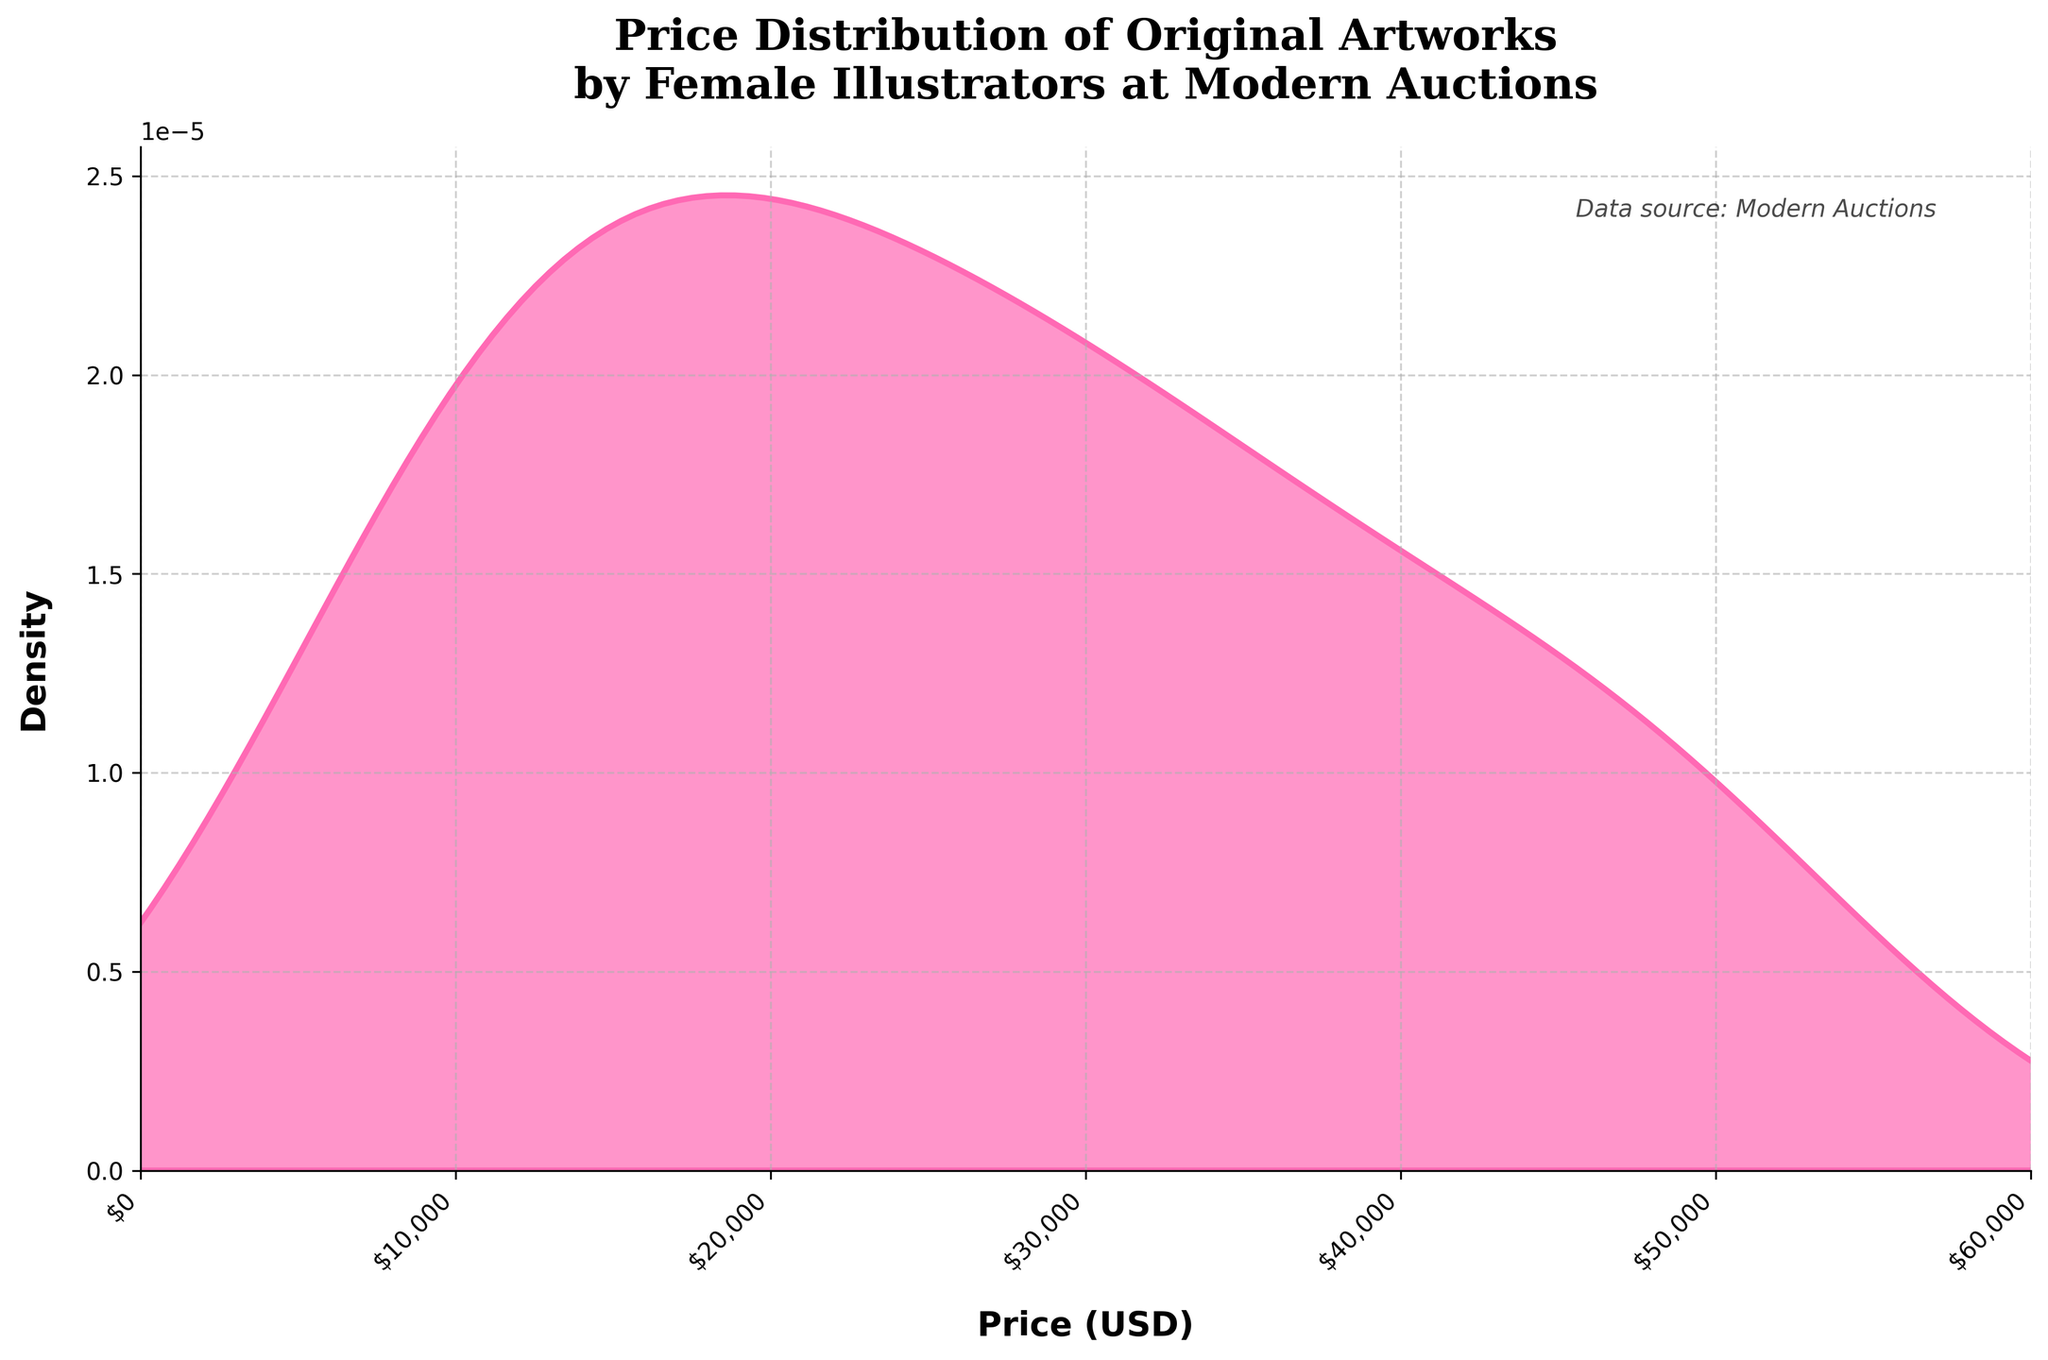What's the title of the plot? The title is usually located at the top of the plot. Here, the title of the plot reads: "Price Distribution of Original Artworks by Female Illustrators at Modern Auctions".
Answer: Price Distribution of Original Artworks by Female Illustrators at Modern Auctions What is the x-axis label of the plot? The x-axis label is found along the horizontal axis of the plot and describes what the values on this axis represent. In the plot, the x-axis label is "Price (USD)".
Answer: Price (USD) What is the range of the x-axis? The x-axis range can be determined by looking at the minimum and maximum values along the horizontal axis. Here, it ranges from 0 to 60000.
Answer: 0 to 60000 What color is used for the density line in the plot? By examining the visual color of the density line in the plot, one can see it is a shade of pink.
Answer: Pink What value has the highest density in the plot? The point with the highest peak in a density plot represents the value with the highest density. Here, this peak occurs at around 21000-25000 USD.
Answer: 21000-25000 USD Which price range shows a relatively low density of artworks? Observing the plot, the areas with lower peaks indicate lower density. The range between 40000 to 60000 USD shows relatively low density.
Answer: 40000 to 60000 USD Is the distribution of artwork prices unimodal or multimodal? A unimodal distribution has one clear peak, while a multimodal distribution has multiple peaks. The given plot seems to have more than one peak, indicating it's multimodal.
Answer: Multimodal What can be inferred about the price distribution around 30000 USD? Around the 30000 USD mark, the density is relatively higher than in other regions, indicating more artworks are sold around this price.
Answer: High density How does the distribution change from 0 to 60000 USD? Starting from 0, the density increases, peaking around 21000-25000 USD, then decreases slightly before showing another peak around 30000-35000 USD, and finally tapering off towards 60000 USD.
Answer: Increases, peaks, decreases, peaks again, then tapers off 